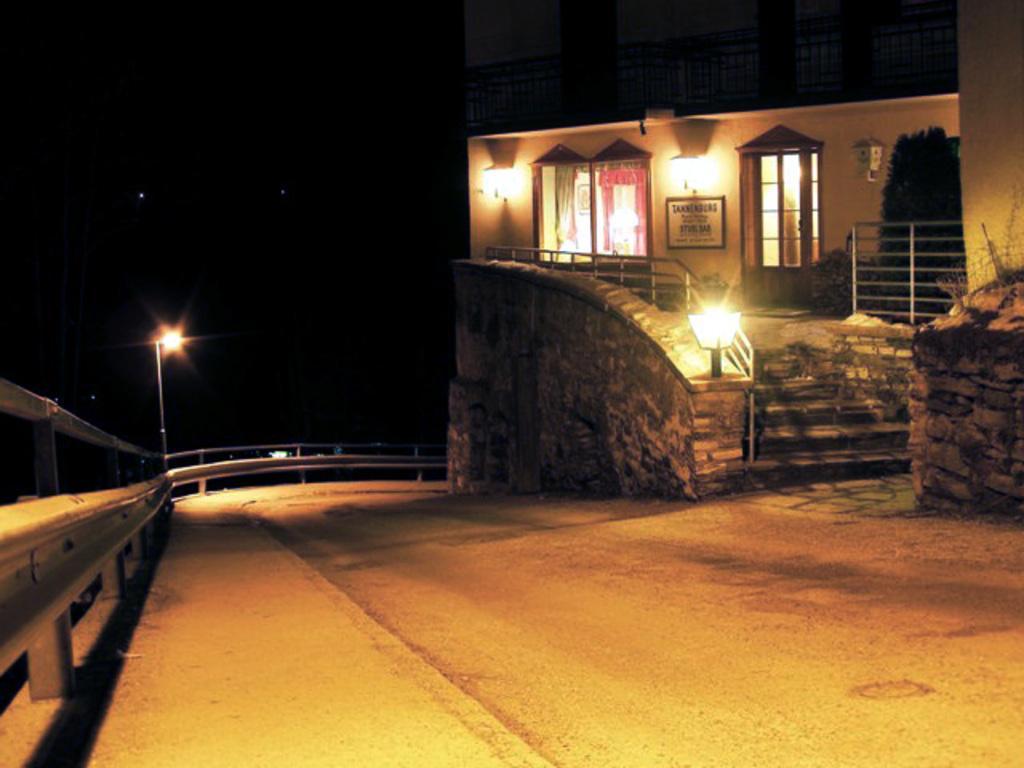In one or two sentences, can you explain what this image depicts? In this picture there is a small house with wooden door and windows. In the front there are some steps and a small lamp post on the granite wall. In the front bottom side there is a road with silver color railing guard. Behind there is a black background. 